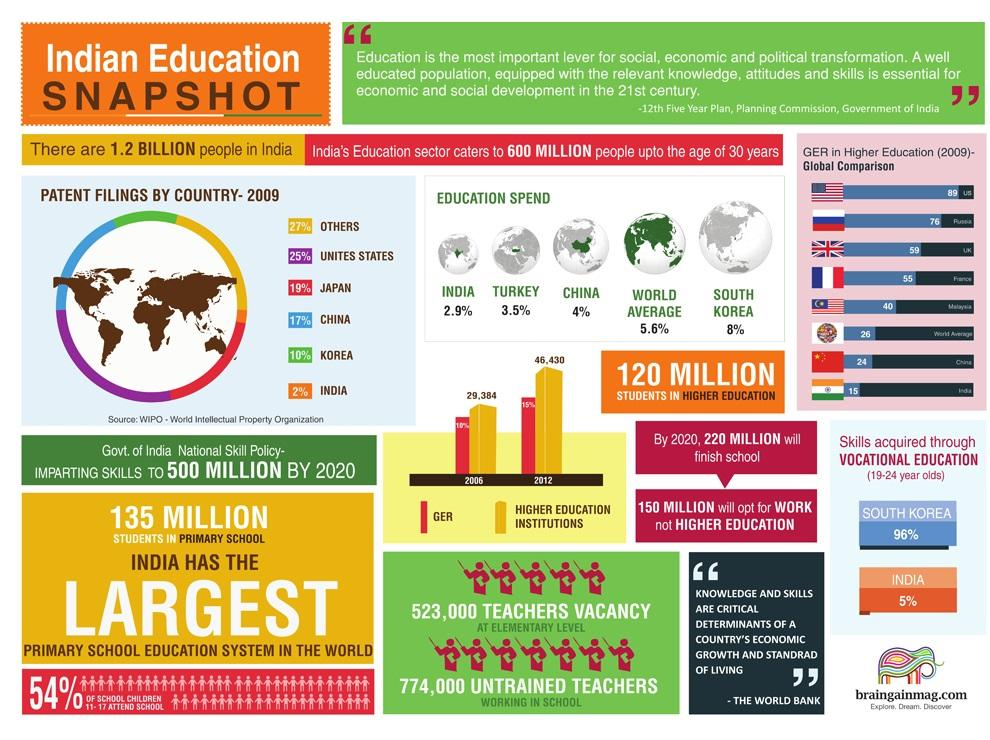Draw attention to some important aspects in this diagram. In South Korea, 96% of students between the ages of 19 and 24 acquire skills through vocational education. The percentage of education spend in China ranges from 2.9% to 4%, with a value of 4% being the highest. In India, it is estimated that only 5% of students in the age range of 19-24 acquire skills through vocational education. Japan has the second highest number of patents filed. A recent study comparing vocational education in South Korea and India found that the percentile gap in skills acquired was 91%. 